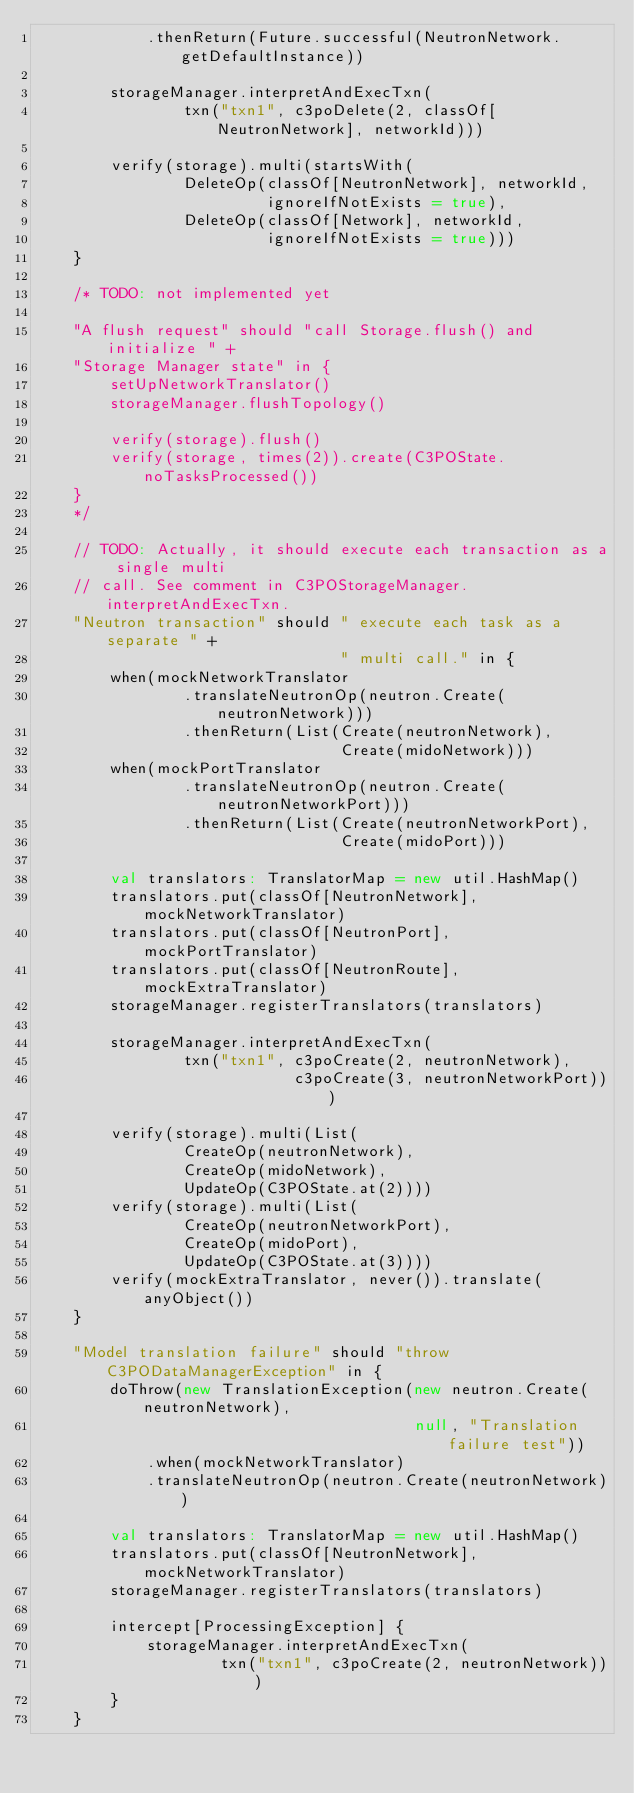<code> <loc_0><loc_0><loc_500><loc_500><_Scala_>            .thenReturn(Future.successful(NeutronNetwork.getDefaultInstance))

        storageManager.interpretAndExecTxn(
                txn("txn1", c3poDelete(2, classOf[NeutronNetwork], networkId)))

        verify(storage).multi(startsWith(
                DeleteOp(classOf[NeutronNetwork], networkId,
                         ignoreIfNotExists = true),
                DeleteOp(classOf[Network], networkId,
                         ignoreIfNotExists = true)))
    }

    /* TODO: not implemented yet

    "A flush request" should "call Storage.flush() and initialize " +
    "Storage Manager state" in {
        setUpNetworkTranslator()
        storageManager.flushTopology()

        verify(storage).flush()
        verify(storage, times(2)).create(C3POState.noTasksProcessed())
    }
    */

    // TODO: Actually, it should execute each transaction as a single multi
    // call. See comment in C3POStorageManager.interpretAndExecTxn.
    "Neutron transaction" should " execute each task as a separate " +
                                 " multi call." in {
        when(mockNetworkTranslator
                .translateNeutronOp(neutron.Create(neutronNetwork)))
                .thenReturn(List(Create(neutronNetwork),
                                 Create(midoNetwork)))
        when(mockPortTranslator
                .translateNeutronOp(neutron.Create(neutronNetworkPort)))
                .thenReturn(List(Create(neutronNetworkPort),
                                 Create(midoPort)))

        val translators: TranslatorMap = new util.HashMap()
        translators.put(classOf[NeutronNetwork], mockNetworkTranslator)
        translators.put(classOf[NeutronPort], mockPortTranslator)
        translators.put(classOf[NeutronRoute], mockExtraTranslator)
        storageManager.registerTranslators(translators)

        storageManager.interpretAndExecTxn(
                txn("txn1", c3poCreate(2, neutronNetwork),
                            c3poCreate(3, neutronNetworkPort)))

        verify(storage).multi(List(
                CreateOp(neutronNetwork),
                CreateOp(midoNetwork),
                UpdateOp(C3POState.at(2))))
        verify(storage).multi(List(
                CreateOp(neutronNetworkPort),
                CreateOp(midoPort),
                UpdateOp(C3POState.at(3))))
        verify(mockExtraTranslator, never()).translate(anyObject())
    }

    "Model translation failure" should "throw C3PODataManagerException" in {
        doThrow(new TranslationException(new neutron.Create(neutronNetwork),
                                         null, "Translation failure test"))
            .when(mockNetworkTranslator)
            .translateNeutronOp(neutron.Create(neutronNetwork))

        val translators: TranslatorMap = new util.HashMap()
        translators.put(classOf[NeutronNetwork], mockNetworkTranslator)
        storageManager.registerTranslators(translators)

        intercept[ProcessingException] {
            storageManager.interpretAndExecTxn(
                    txn("txn1", c3poCreate(2, neutronNetwork)))
        }
    }
</code> 